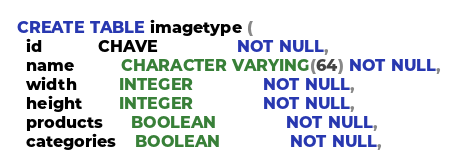Convert code to text. <code><loc_0><loc_0><loc_500><loc_500><_SQL_>CREATE TABLE imagetype (
  id            CHAVE                 NOT NULL,
  name          CHARACTER VARYING(64) NOT NULL,
  width         INTEGER               NOT NULL,
  height        INTEGER               NOT NULL,
  products      BOOLEAN               NOT NULL,
  categories    BOOLEAN               NOT NULL,</code> 